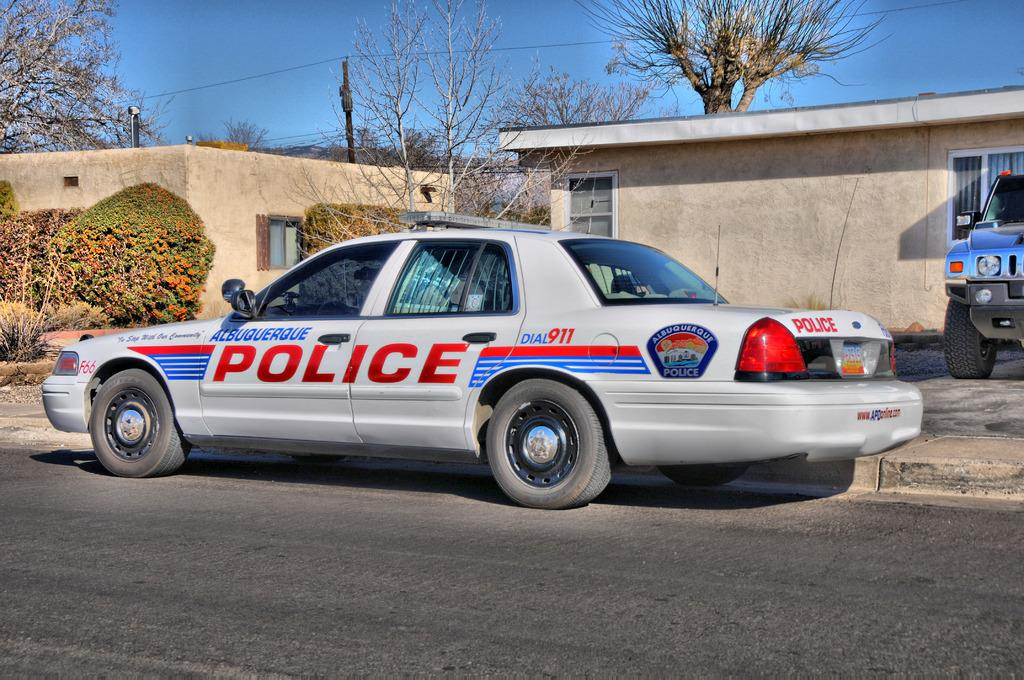<image>
Offer a succinct explanation of the picture presented. A Police Car of Albuquerque parked in front of a porch . 